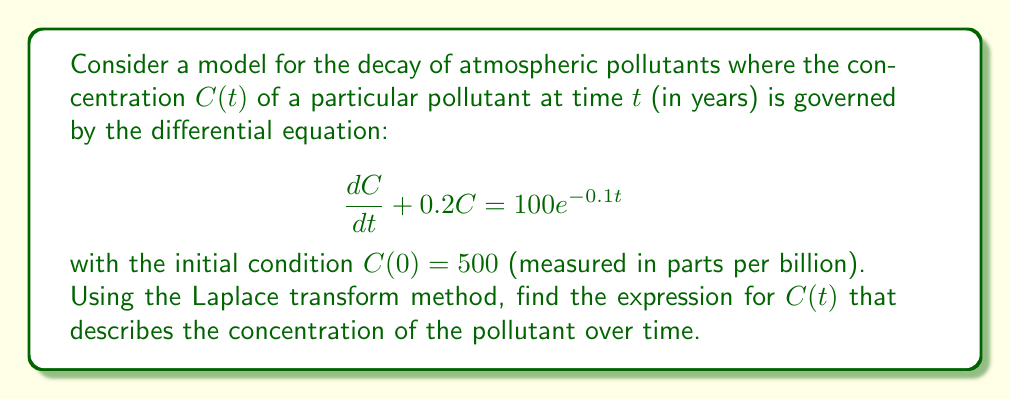Provide a solution to this math problem. Let's solve this step-by-step using the Laplace transform method:

1) Take the Laplace transform of both sides of the equation:
   $$\mathcal{L}\left\{\frac{dC}{dt} + 0.2C\right\} = \mathcal{L}\{100e^{-0.1t}\}$$

2) Using Laplace transform properties:
   $$s\mathcal{L}\{C\} - C(0) + 0.2\mathcal{L}\{C\} = \frac{100}{s+0.1}$$

3) Let $\mathcal{L}\{C\} = F(s)$. Substituting the initial condition:
   $$sF(s) - 500 + 0.2F(s) = \frac{100}{s+0.1}$$

4) Simplify:
   $$(s+0.2)F(s) = 500 + \frac{100}{s+0.1}$$

5) Solve for $F(s)$:
   $$F(s) = \frac{500}{s+0.2} + \frac{100}{(s+0.2)(s+0.1)}$$

6) Decompose the fraction:
   $$F(s) = \frac{500}{s+0.2} + \frac{1000}{s+0.2} - \frac{1000}{s+0.1}$$

7) Take the inverse Laplace transform:
   $$C(t) = 500e^{-0.2t} + 1000e^{-0.2t} - 1000e^{-0.1t}$$

8) Simplify:
   $$C(t) = 1500e^{-0.2t} - 1000e^{-0.1t}$$
Answer: $C(t) = 1500e^{-0.2t} - 1000e^{-0.1t}$ 